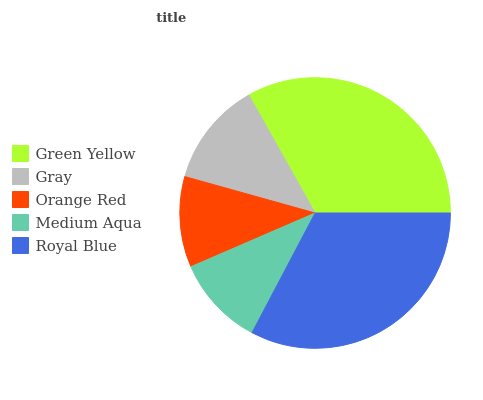Is Medium Aqua the minimum?
Answer yes or no. Yes. Is Green Yellow the maximum?
Answer yes or no. Yes. Is Gray the minimum?
Answer yes or no. No. Is Gray the maximum?
Answer yes or no. No. Is Green Yellow greater than Gray?
Answer yes or no. Yes. Is Gray less than Green Yellow?
Answer yes or no. Yes. Is Gray greater than Green Yellow?
Answer yes or no. No. Is Green Yellow less than Gray?
Answer yes or no. No. Is Gray the high median?
Answer yes or no. Yes. Is Gray the low median?
Answer yes or no. Yes. Is Green Yellow the high median?
Answer yes or no. No. Is Medium Aqua the low median?
Answer yes or no. No. 